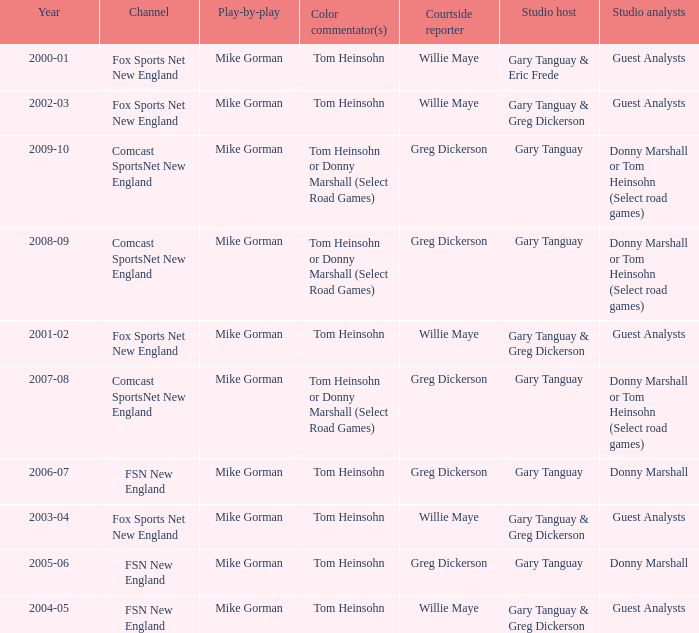Which Color commentator has a Channel of fsn new england, and a Year of 2004-05? Tom Heinsohn. 